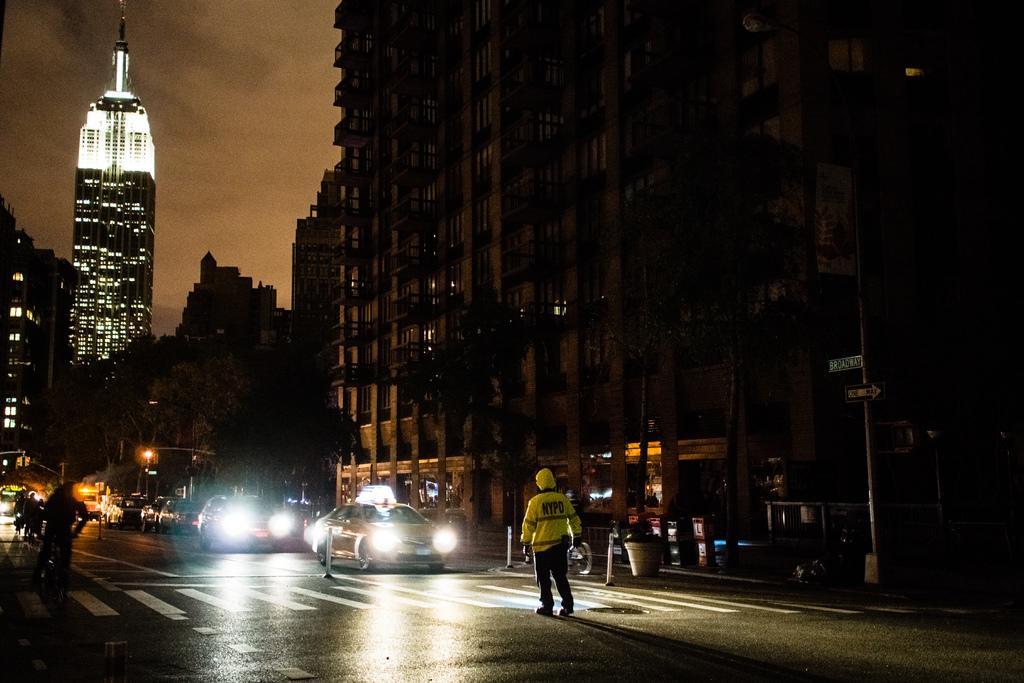In one or two sentences, can you explain what this image depicts? In the center of the image we can see a man standing on the road. On the left there are people riding bicycles and there are cars on the road. In the background there are buildings, poles, trees and sky. 